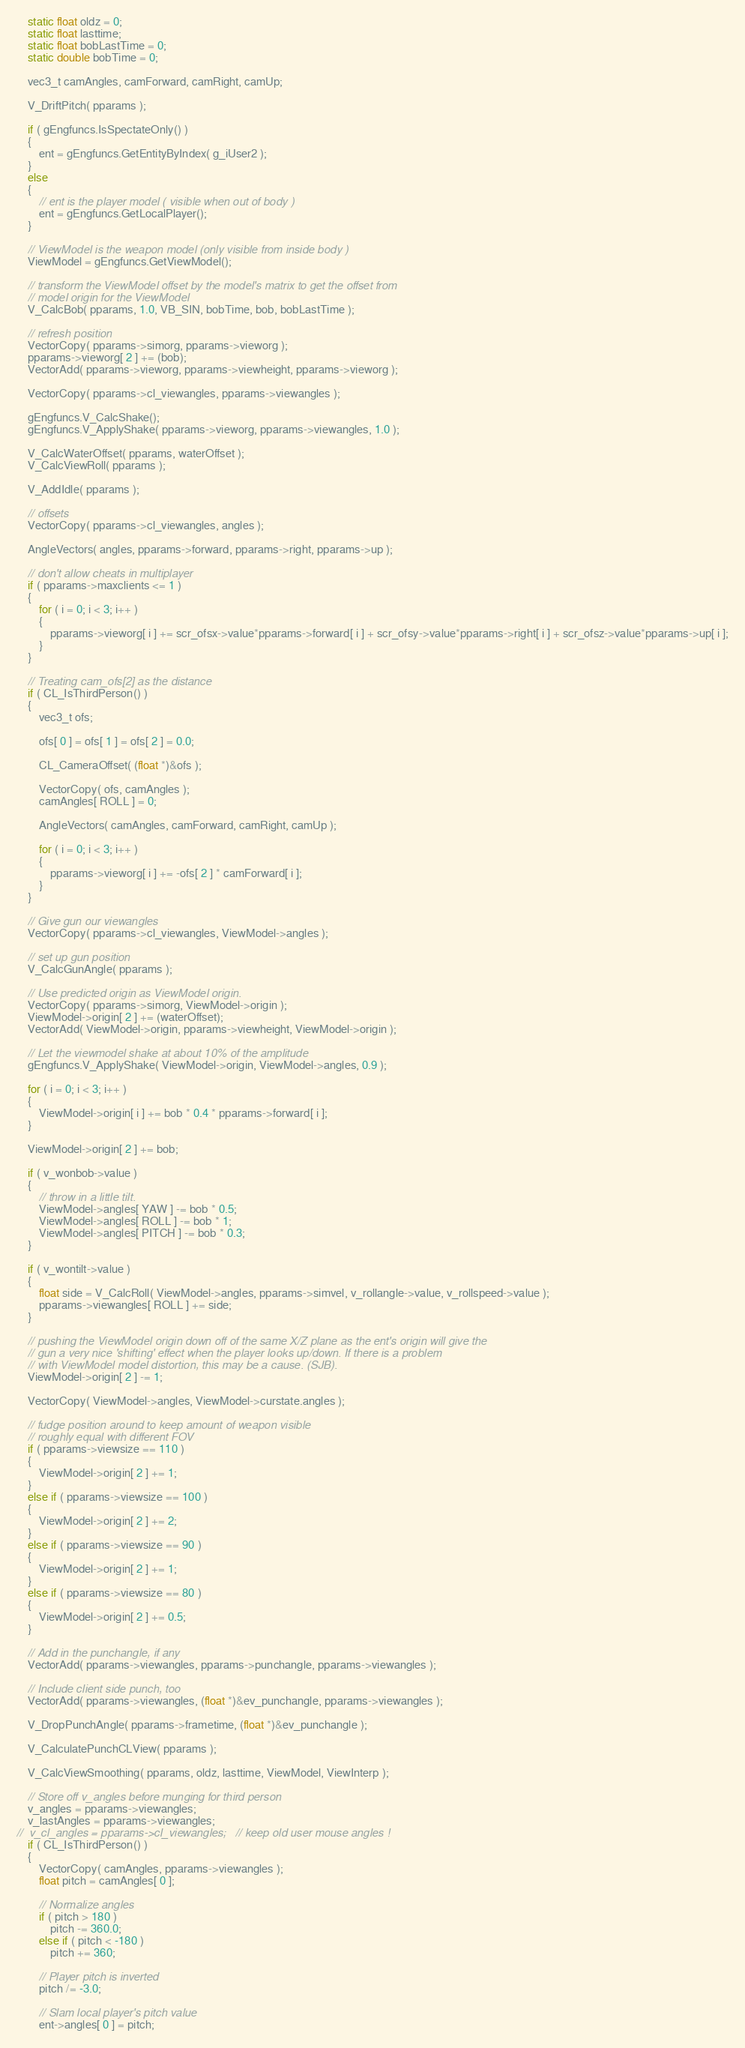Convert code to text. <code><loc_0><loc_0><loc_500><loc_500><_C++_>
	static float oldz = 0;
	static float lasttime;
	static float bobLastTime = 0;
	static double bobTime = 0;

	vec3_t camAngles, camForward, camRight, camUp;

	V_DriftPitch( pparams );

	if ( gEngfuncs.IsSpectateOnly() )
	{
		ent = gEngfuncs.GetEntityByIndex( g_iUser2 );
	}
	else
	{
		// ent is the player model ( visible when out of body )
		ent = gEngfuncs.GetLocalPlayer();
	}

	// ViewModel is the weapon model (only visible from inside body )
	ViewModel = gEngfuncs.GetViewModel();

	// transform the ViewModel offset by the model's matrix to get the offset from
	// model origin for the ViewModel
	V_CalcBob( pparams, 1.0, VB_SIN, bobTime, bob, bobLastTime );

	// refresh position
	VectorCopy( pparams->simorg, pparams->vieworg );
	pparams->vieworg[ 2 ] += (bob);
	VectorAdd( pparams->vieworg, pparams->viewheight, pparams->vieworg );

	VectorCopy( pparams->cl_viewangles, pparams->viewangles );

	gEngfuncs.V_CalcShake();
	gEngfuncs.V_ApplyShake( pparams->vieworg, pparams->viewangles, 1.0 );

	V_CalcWaterOffset( pparams, waterOffset );
	V_CalcViewRoll( pparams );

	V_AddIdle( pparams );

	// offsets
	VectorCopy( pparams->cl_viewangles, angles );

	AngleVectors( angles, pparams->forward, pparams->right, pparams->up );

	// don't allow cheats in multiplayer
	if ( pparams->maxclients <= 1 )
	{
		for ( i = 0; i < 3; i++ )
		{
			pparams->vieworg[ i ] += scr_ofsx->value*pparams->forward[ i ] + scr_ofsy->value*pparams->right[ i ] + scr_ofsz->value*pparams->up[ i ];
		}
	}

	// Treating cam_ofs[2] as the distance
	if ( CL_IsThirdPerson() )
	{
		vec3_t ofs;

		ofs[ 0 ] = ofs[ 1 ] = ofs[ 2 ] = 0.0;

		CL_CameraOffset( (float *)&ofs );

		VectorCopy( ofs, camAngles );
		camAngles[ ROLL ] = 0;

		AngleVectors( camAngles, camForward, camRight, camUp );

		for ( i = 0; i < 3; i++ )
		{
			pparams->vieworg[ i ] += -ofs[ 2 ] * camForward[ i ];
		}
	}

	// Give gun our viewangles
	VectorCopy( pparams->cl_viewangles, ViewModel->angles );

	// set up gun position
	V_CalcGunAngle( pparams );

	// Use predicted origin as ViewModel origin.
	VectorCopy( pparams->simorg, ViewModel->origin );
	ViewModel->origin[ 2 ] += (waterOffset);
	VectorAdd( ViewModel->origin, pparams->viewheight, ViewModel->origin );

	// Let the viewmodel shake at about 10% of the amplitude
	gEngfuncs.V_ApplyShake( ViewModel->origin, ViewModel->angles, 0.9 );

	for ( i = 0; i < 3; i++ )
	{
		ViewModel->origin[ i ] += bob * 0.4 * pparams->forward[ i ];
	}

	ViewModel->origin[ 2 ] += bob;

	if ( v_wonbob->value )
	{
		// throw in a little tilt.
		ViewModel->angles[ YAW ] -= bob * 0.5;
		ViewModel->angles[ ROLL ] -= bob * 1;
		ViewModel->angles[ PITCH ] -= bob * 0.3;
	}

	if ( v_wontilt->value )
	{
		float side = V_CalcRoll( ViewModel->angles, pparams->simvel, v_rollangle->value, v_rollspeed->value );
		pparams->viewangles[ ROLL ] += side;
	}

	// pushing the ViewModel origin down off of the same X/Z plane as the ent's origin will give the
	// gun a very nice 'shifting' effect when the player looks up/down. If there is a problem
	// with ViewModel model distortion, this may be a cause. (SJB). 
	ViewModel->origin[ 2 ] -= 1;

	VectorCopy( ViewModel->angles, ViewModel->curstate.angles );

	// fudge position around to keep amount of weapon visible
	// roughly equal with different FOV
	if ( pparams->viewsize == 110 )
	{
		ViewModel->origin[ 2 ] += 1;
	}
	else if ( pparams->viewsize == 100 )
	{
		ViewModel->origin[ 2 ] += 2;
	}
	else if ( pparams->viewsize == 90 )
	{
		ViewModel->origin[ 2 ] += 1;
	}
	else if ( pparams->viewsize == 80 )
	{
		ViewModel->origin[ 2 ] += 0.5;
	}

	// Add in the punchangle, if any
	VectorAdd( pparams->viewangles, pparams->punchangle, pparams->viewangles );

	// Include client side punch, too
	VectorAdd( pparams->viewangles, (float *)&ev_punchangle, pparams->viewangles );

	V_DropPunchAngle( pparams->frametime, (float *)&ev_punchangle );

	V_CalculatePunchCLView( pparams );

	V_CalcViewSmoothing( pparams, oldz, lasttime, ViewModel, ViewInterp );

	// Store off v_angles before munging for third person
	v_angles = pparams->viewangles;
	v_lastAngles = pparams->viewangles;
//	v_cl_angles = pparams->cl_viewangles;	// keep old user mouse angles !
	if ( CL_IsThirdPerson() )
	{
		VectorCopy( camAngles, pparams->viewangles );
		float pitch = camAngles[ 0 ];

		// Normalize angles
		if ( pitch > 180 )
			pitch -= 360.0;
		else if ( pitch < -180 )
			pitch += 360;

		// Player pitch is inverted
		pitch /= -3.0;

		// Slam local player's pitch value
		ent->angles[ 0 ] = pitch;</code> 